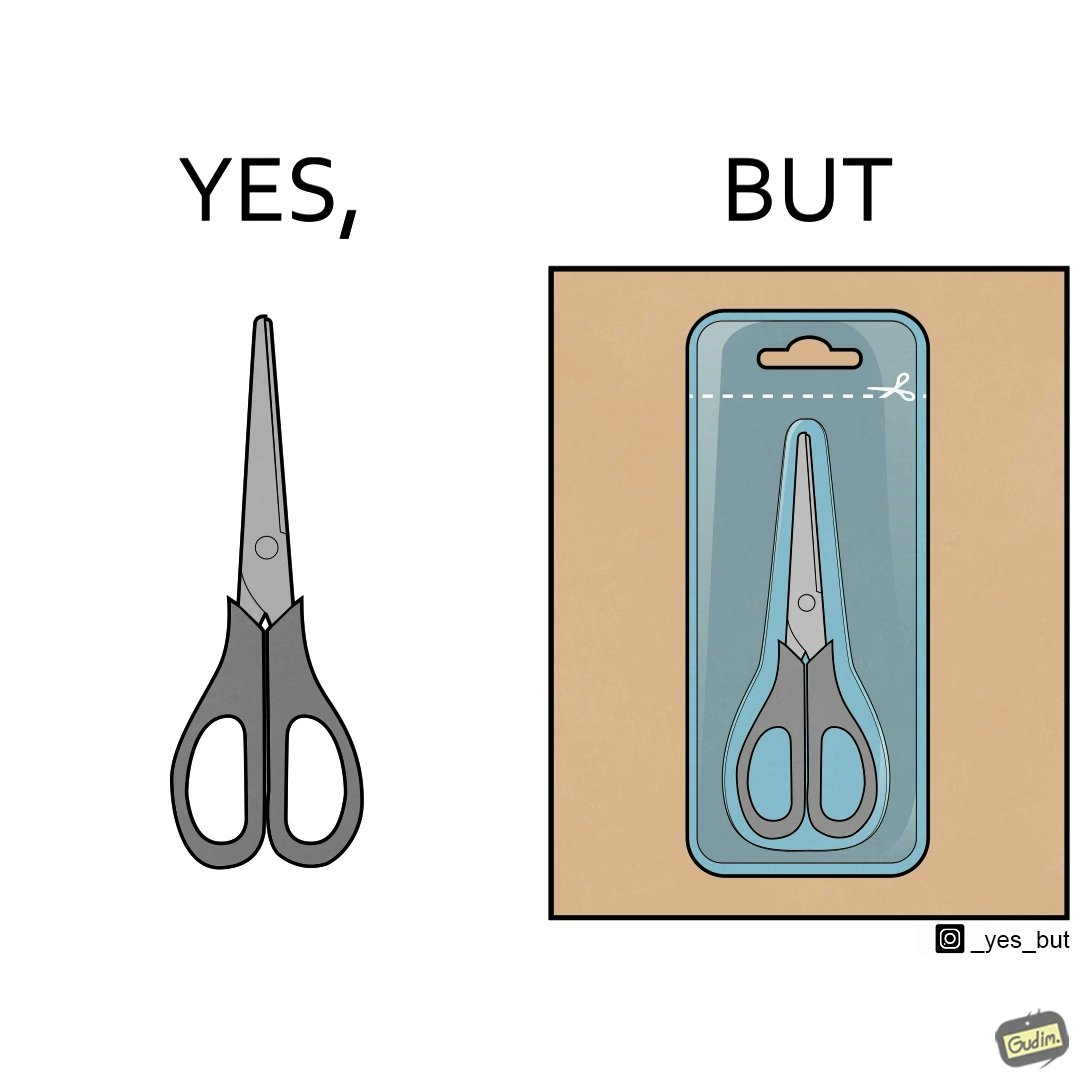Explain the humor or irony in this image. the image is funny, as the marking at the top of the packaging shows that you would need a pair of scissors to in-turn cut open the pair of scissors that is inside the packaging. 